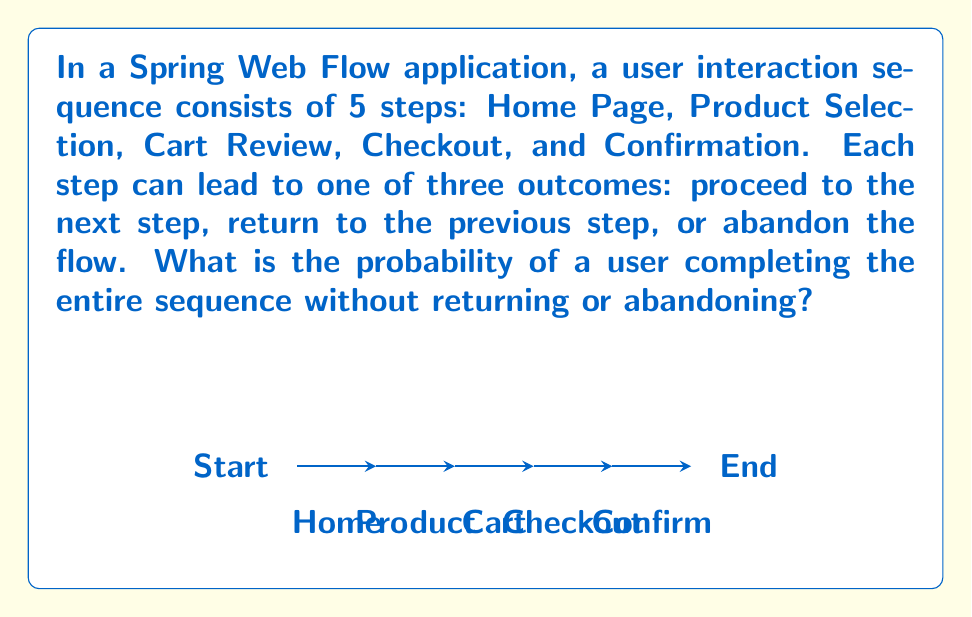Solve this math problem. Let's approach this step-by-step:

1) At each step, there are three possible outcomes:
   - Proceed to next step (P)
   - Return to previous step (R)
   - Abandon the flow (A)

2) The probability of each outcome is:
   $P(P) = \frac{1}{3}$, $P(R) = \frac{1}{3}$, $P(A) = \frac{1}{3}$

3) To complete the sequence without returning or abandoning, the user must choose to proceed (P) at each of the 5 steps.

4) The probability of this happening is the product of the individual probabilities of proceeding at each step:

   $$P(\text{complete sequence}) = P(P)^5 = (\frac{1}{3})^5$$

5) Let's calculate this:
   $$(\frac{1}{3})^5 = \frac{1}{3^5} = \frac{1}{243} \approx 0.004115$$

Therefore, the probability of a user completing the entire sequence without returning or abandoning is $\frac{1}{243}$ or approximately 0.4115%.
Answer: $\frac{1}{243}$ 